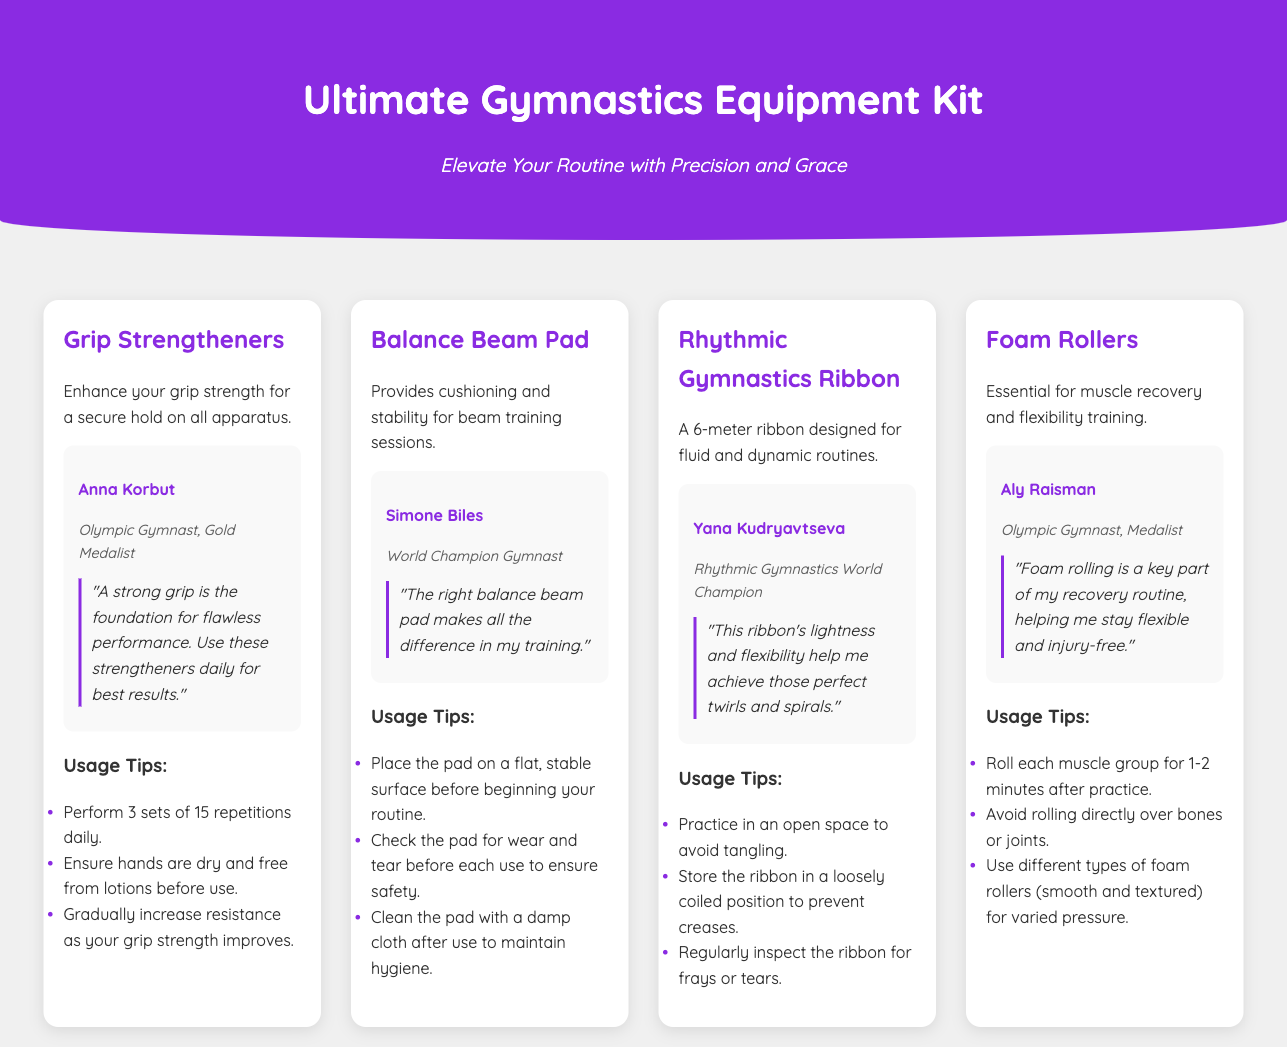What is the title of the document? The title of the document is provided in the header section of the HTML, stating "Ultimate Gymnastics Equipment Kit".
Answer: Ultimate Gymnastics Equipment Kit Who is the Olympic Gymnast mentioned in the Grip Strengtheners section? The Grip Strengtheners section features an athlete profile, which mentions Anna Korbut as the Olympic Gymnast.
Answer: Anna Korbut What is the main usage tip for the Balance Beam Pad? The document includes several usage tips for the Balance Beam Pad, one of which is to "Place the pad on a flat, stable surface before beginning your routine."
Answer: Place the pad on a flat, stable surface How long is the Rhythmic Gymnastics Ribbon? The document states that the ribbon designed for rhythmic gymnastics is "A 6-meter ribbon."
Answer: 6 meters What does Aly Raisman recommend for muscle recovery? In the Foam Rollers section, Aly Raisman emphasizes foam rolling as essential for recovery, stating it "is a key part of my recovery routine."
Answer: Foam rolling Which product features an athlete named Simone Biles? The product associated with Simone Biles is the Balance Beam Pad, as indicated in her athlete profile within that section.
Answer: Balance Beam Pad What is the function of Foam Rollers as mentioned in the document? The document describes the Foam Rollers as "Essential for muscle recovery and flexibility training," indicating their primary function.
Answer: Muscle recovery and flexibility training What advice is given about the Rhythmic Gymnastics Ribbon storage? The usage tips for the Rhythmic Gymnastics Ribbon include the advice to "Store the ribbon in a loosely coiled position to prevent creases."
Answer: Store in a loosely coiled position 